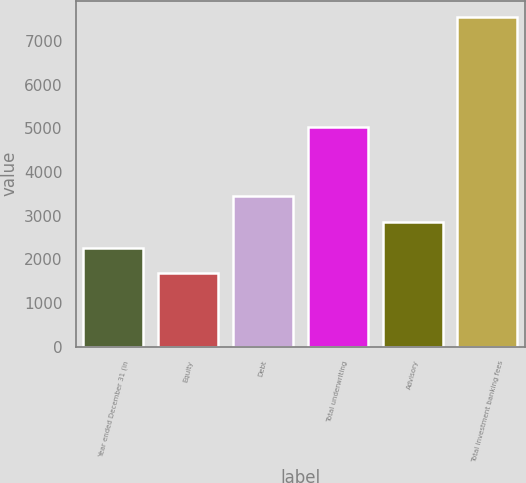Convert chart. <chart><loc_0><loc_0><loc_500><loc_500><bar_chart><fcel>Year ended December 31 (in<fcel>Equity<fcel>Debt<fcel>Total underwriting<fcel>Advisory<fcel>Total investment banking fees<nl><fcel>2270.6<fcel>1684<fcel>3443.8<fcel>5031<fcel>2857.2<fcel>7550<nl></chart> 